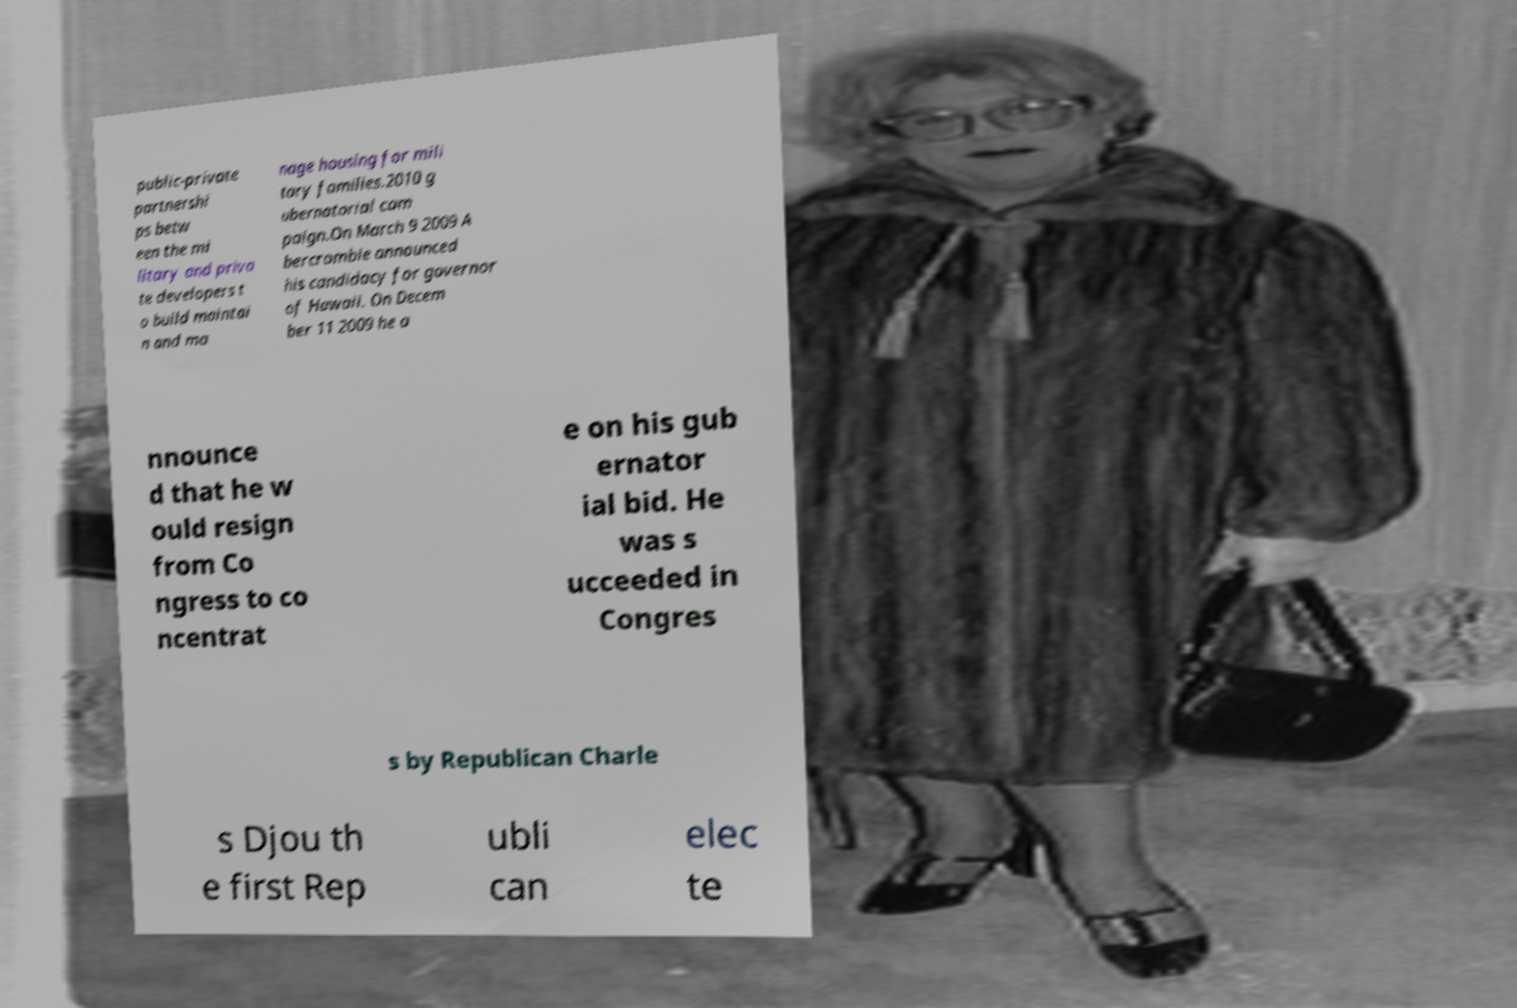Can you accurately transcribe the text from the provided image for me? public-private partnershi ps betw een the mi litary and priva te developers t o build maintai n and ma nage housing for mili tary families.2010 g ubernatorial cam paign.On March 9 2009 A bercrombie announced his candidacy for governor of Hawaii. On Decem ber 11 2009 he a nnounce d that he w ould resign from Co ngress to co ncentrat e on his gub ernator ial bid. He was s ucceeded in Congres s by Republican Charle s Djou th e first Rep ubli can elec te 